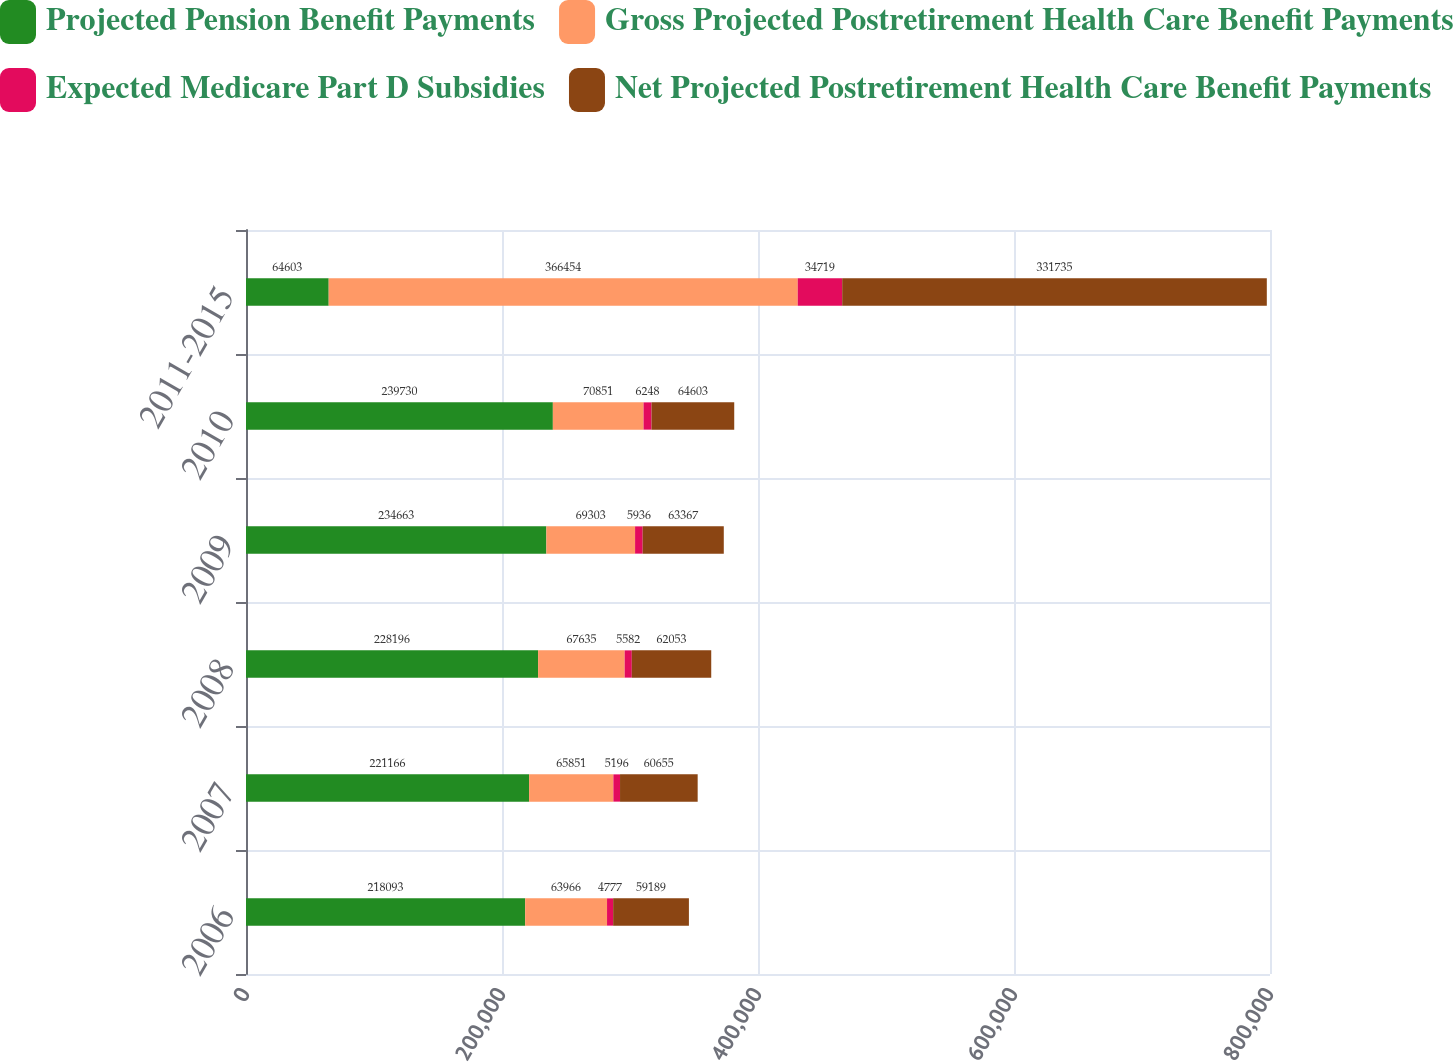Convert chart. <chart><loc_0><loc_0><loc_500><loc_500><stacked_bar_chart><ecel><fcel>2006<fcel>2007<fcel>2008<fcel>2009<fcel>2010<fcel>2011-2015<nl><fcel>Projected Pension Benefit Payments<fcel>218093<fcel>221166<fcel>228196<fcel>234663<fcel>239730<fcel>64603<nl><fcel>Gross Projected Postretirement Health Care Benefit Payments<fcel>63966<fcel>65851<fcel>67635<fcel>69303<fcel>70851<fcel>366454<nl><fcel>Expected Medicare Part D Subsidies<fcel>4777<fcel>5196<fcel>5582<fcel>5936<fcel>6248<fcel>34719<nl><fcel>Net Projected Postretirement Health Care Benefit Payments<fcel>59189<fcel>60655<fcel>62053<fcel>63367<fcel>64603<fcel>331735<nl></chart> 